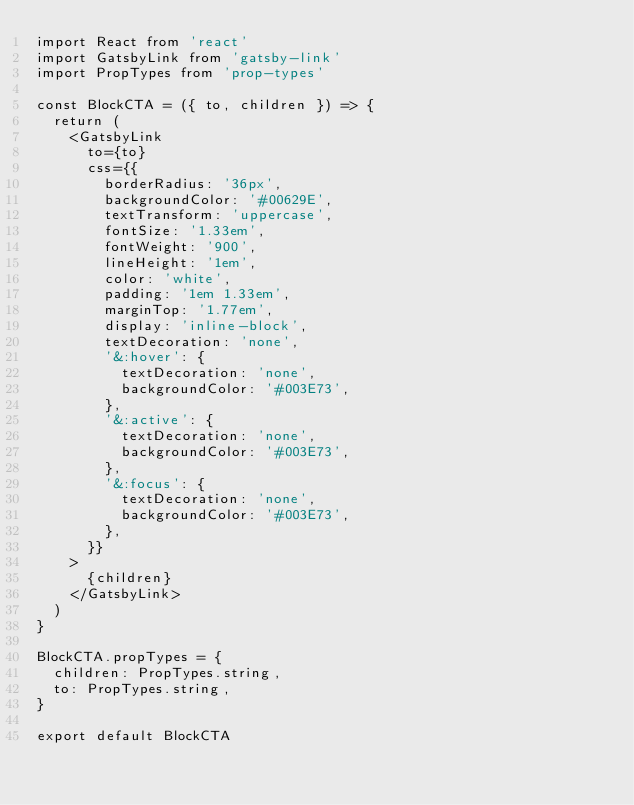Convert code to text. <code><loc_0><loc_0><loc_500><loc_500><_JavaScript_>import React from 'react'
import GatsbyLink from 'gatsby-link'
import PropTypes from 'prop-types'

const BlockCTA = ({ to, children }) => {
  return (
    <GatsbyLink
      to={to}
      css={{
        borderRadius: '36px',
        backgroundColor: '#00629E',
        textTransform: 'uppercase',
        fontSize: '1.33em',
        fontWeight: '900',
        lineHeight: '1em',
        color: 'white',
        padding: '1em 1.33em',
        marginTop: '1.77em',
        display: 'inline-block',
        textDecoration: 'none',
        '&:hover': {
          textDecoration: 'none',
          backgroundColor: '#003E73',
        },
        '&:active': {
          textDecoration: 'none',
          backgroundColor: '#003E73',
        },
        '&:focus': {
          textDecoration: 'none',
          backgroundColor: '#003E73',
        },
      }}
    >
      {children}
    </GatsbyLink>
  )
}

BlockCTA.propTypes = {
  children: PropTypes.string,
  to: PropTypes.string,
}

export default BlockCTA
</code> 